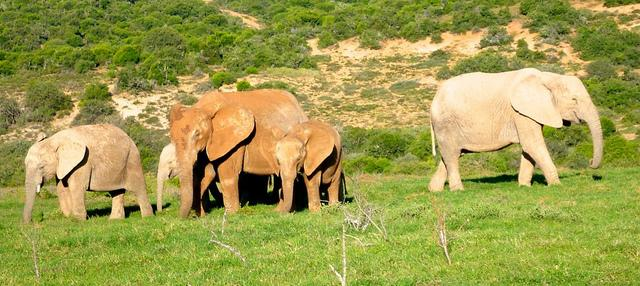What color is the skin of the dirty elephant in the middle?

Choices:
A) ivory
B) bronze
C) pink
D) gray bronze 